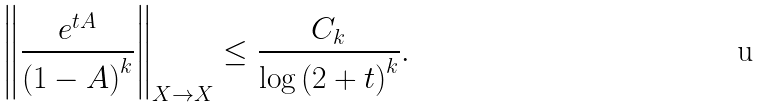<formula> <loc_0><loc_0><loc_500><loc_500>\left \| \frac { e ^ { t A } } { \left ( 1 - A \right ) ^ { k } } \right \| _ { X \rightarrow X } \leq \frac { C _ { k } } { \log \left ( 2 + t \right ) ^ { k } } .</formula> 